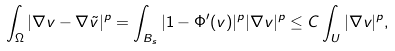<formula> <loc_0><loc_0><loc_500><loc_500>\int _ { \Omega } | \nabla v - \nabla \tilde { v } | ^ { p } = \int _ { B _ { s } } | 1 - \Phi ^ { \prime } ( v ) | ^ { p } | \nabla v | ^ { p } \leq C \int _ { U } | \nabla v | ^ { p } ,</formula> 